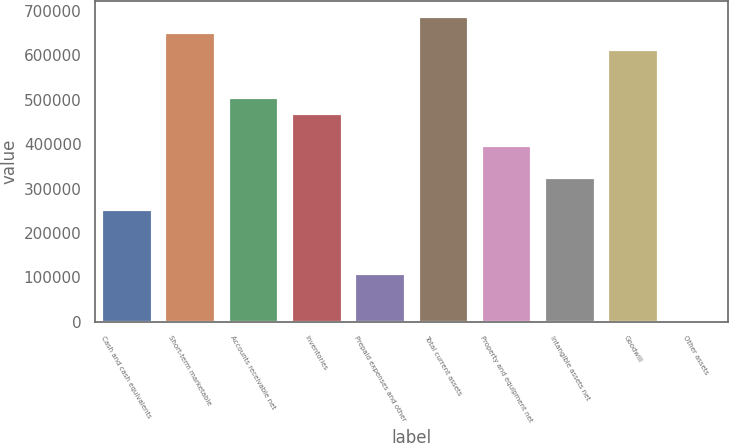Convert chart. <chart><loc_0><loc_0><loc_500><loc_500><bar_chart><fcel>Cash and cash equivalents<fcel>Short-term marketable<fcel>Accounts receivable net<fcel>Inventories<fcel>Prepaid expenses and other<fcel>Total current assets<fcel>Property and equipment net<fcel>Intangible assets net<fcel>Goodwill<fcel>Other assets<nl><fcel>253558<fcel>651533<fcel>506815<fcel>470636<fcel>108840<fcel>687712<fcel>398276<fcel>325918<fcel>615354<fcel>302<nl></chart> 